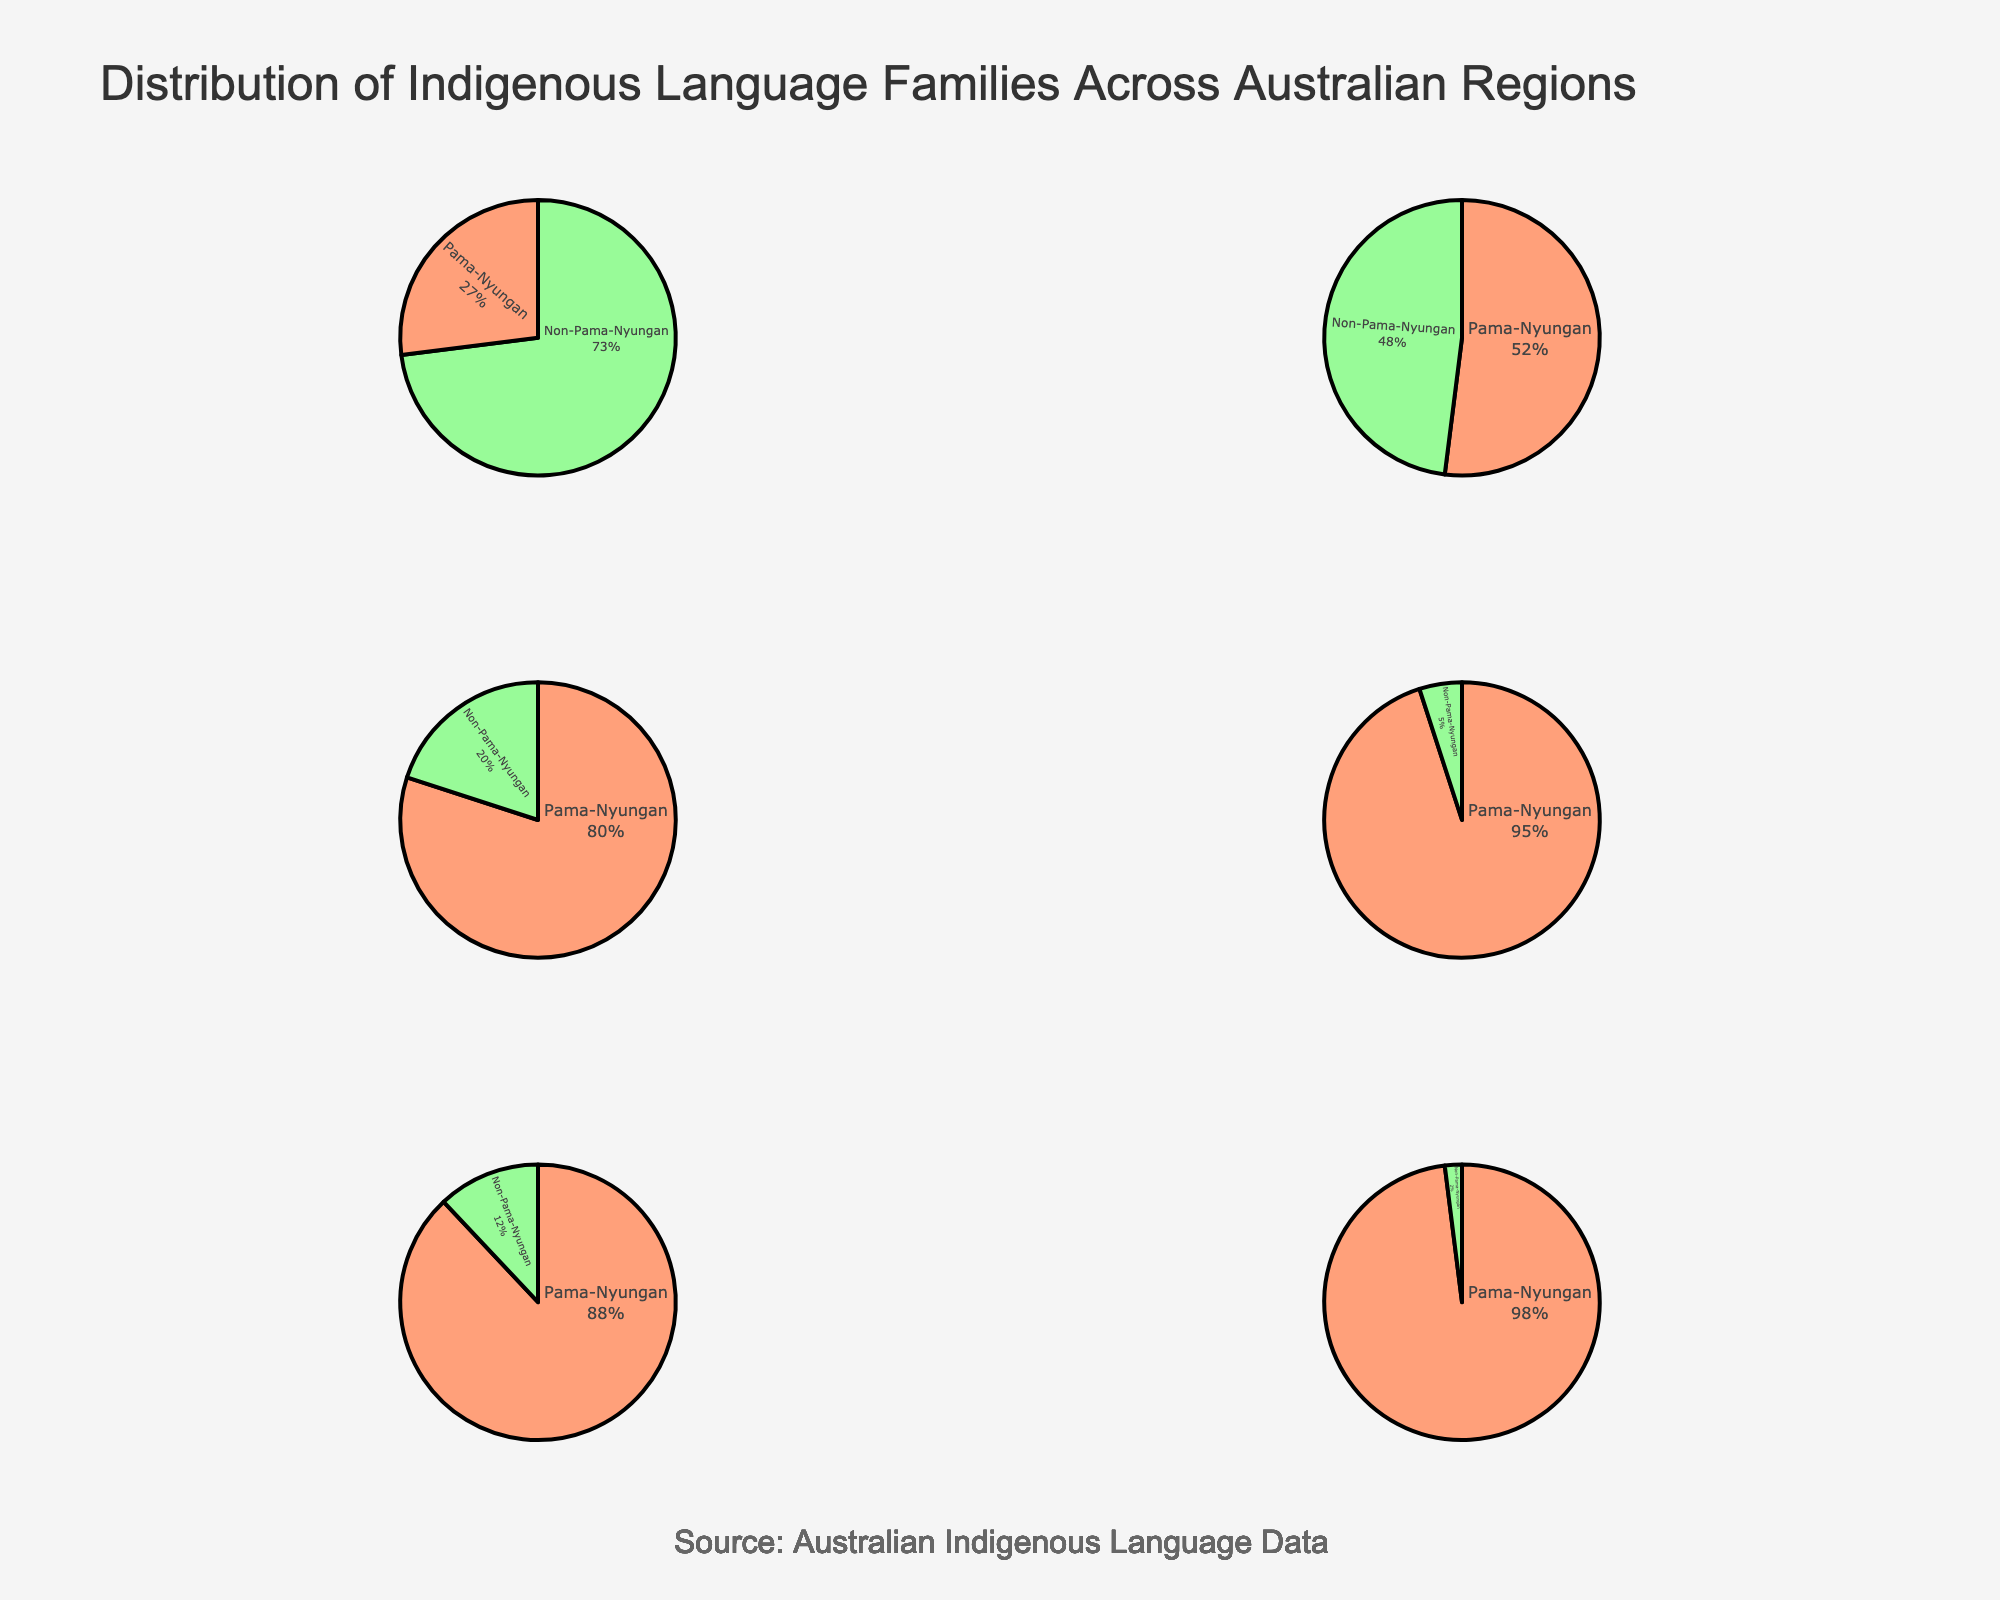What is the most common language family in Victoria? The pie chart for Victoria shows two sections. The larger section, taking up the majority of the pie, represents the Pama-Nyungan language family.
Answer: Pama-Nyungan Which region has the highest proportion of Non-Pama-Nyungan languages? The pie chart for Northern Territory shows two sections, with the Non-Pama-Nyungan making up the majority of the pie compared to other regions.
Answer: Northern Territory What is the total number of Pama-Nyungan languages in Victoria and New South Wales combined? Victoria has 98 Pama-Nyungan languages, and New South Wales has 95. Adding these together: 98 + 95.
Answer: 193 How do the proportions of Pama-Nyungan languages compare between South Australia and Queensland? South Australia’s pie chart shows 88 Pama-Nyungan languages, while Queensland's shows 80. The percentage distribution for Pama-Nyungan is higher in South Australia.
Answer: South Australia has a higher proportion Are there any regions where Non-Pama-Nyungan languages make up less than 10% of the total? Both Victoria and New South Wales have significantly smaller sections for Non-Pama-Nyungan languages, evident in their pie charts showing only 2 and 5 Non-Pama-Nyungan languages respectively.
Answer: Victoria and New South Wales Which language family is more dominant in Western Australia, and by what approximate percentage? The pie chart for Western Australia shows two sections, with Pama-Nyungan slightly larger than Non-Pama-Nyungan. To estimate, Pama-Nyungan is approximately 52% compared to Non-Pama-Nyungan.
Answer: Pama-Nyungan by approximately 52% Which region has nearly equal proportions of Pama-Nyungan and Non-Pama-Nyungan languages? Western Australia’s pie chart is the closest to showing equal sections for both language families, each category making roughly half of the total.
Answer: Western Australia How many more Pama-Nyungan languages are there in New South Wales compared to Queensland? New South Wales has 95 Pama-Nyungan languages and Queensland has 80. Subtracting these numbers: 95 - 80.
Answer: 15 Does any region have exactly 100 languages in total? Reviewing the pie charts, no region’s total number of languages adds up to exactly 100.
Answer: No What is the ratio of Pama-Nyungan to Non-Pama-Nyungan languages in the Northern Territory? Northern Territory has 27 Pama-Nyungan and 73 Non-Pama-Nyungan languages. The ratio is 27:73.
Answer: 27:73 